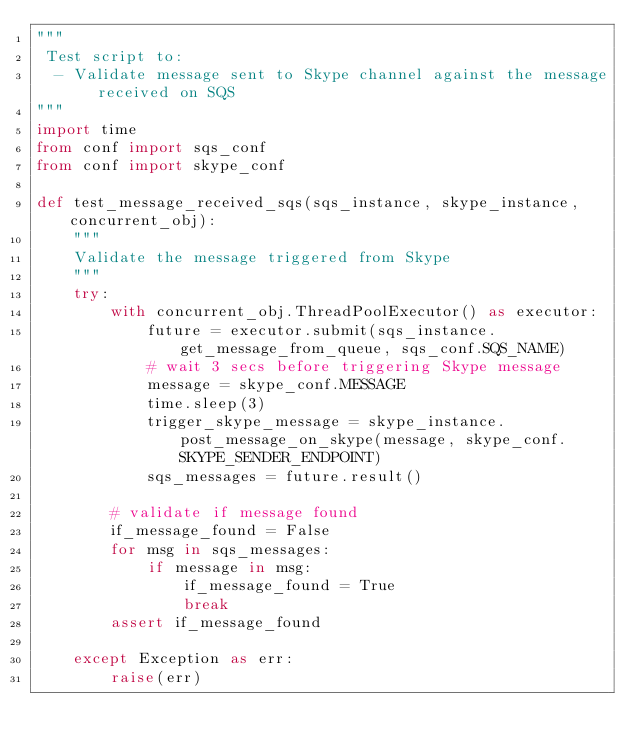<code> <loc_0><loc_0><loc_500><loc_500><_Python_>"""
 Test script to:
  - Validate message sent to Skype channel against the message received on SQS
"""
import time
from conf import sqs_conf
from conf import skype_conf

def test_message_received_sqs(sqs_instance, skype_instance, concurrent_obj):
    """
    Validate the message triggered from Skype
    """
    try:
        with concurrent_obj.ThreadPoolExecutor() as executor:
            future = executor.submit(sqs_instance.get_message_from_queue, sqs_conf.SQS_NAME)
            # wait 3 secs before triggering Skype message
            message = skype_conf.MESSAGE
            time.sleep(3)
            trigger_skype_message = skype_instance.post_message_on_skype(message, skype_conf.SKYPE_SENDER_ENDPOINT)
            sqs_messages = future.result()

        # validate if message found
        if_message_found = False
        for msg in sqs_messages:
            if message in msg:
                if_message_found = True
                break
        assert if_message_found

    except Exception as err:
        raise(err)
</code> 